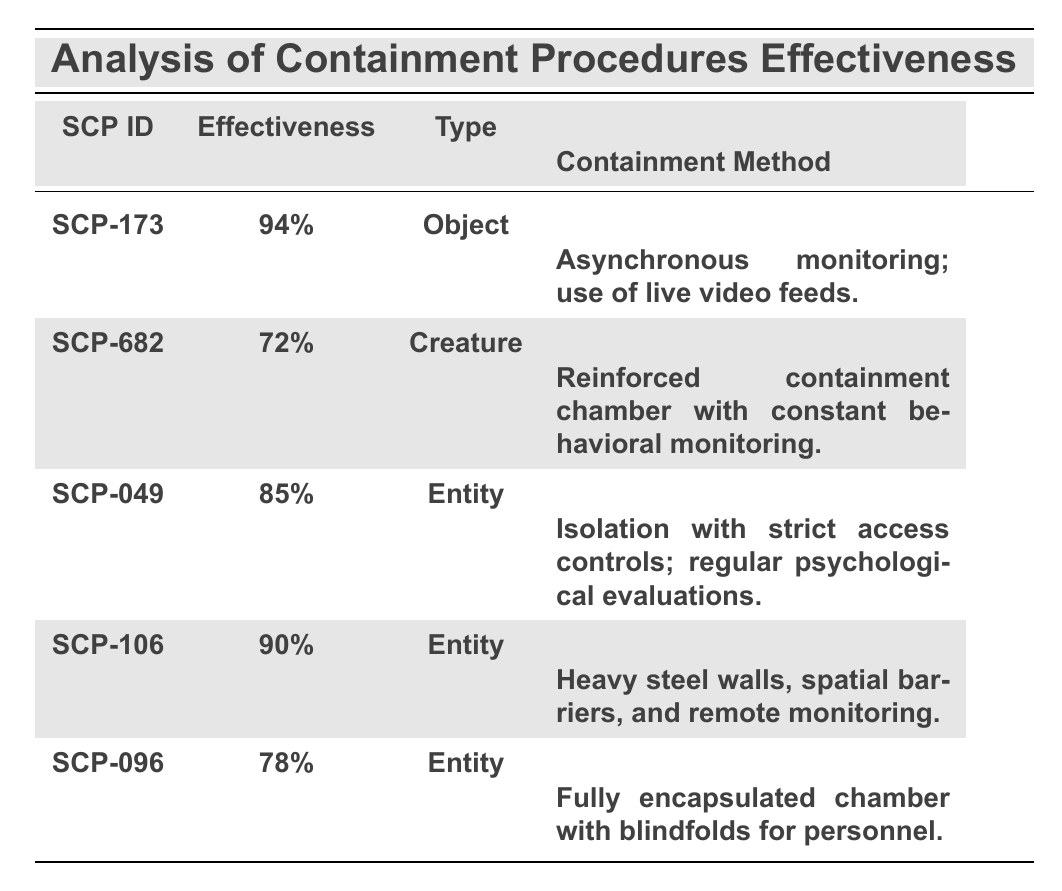What is the containment procedure effectiveness percentage for SCP-682? SCP-682's effectiveness percentage is provided directly in the table under the "Effectiveness" column. It shows "72%".
Answer: 72% Which SCP has the highest effectiveness in containment procedures? By comparing the effectiveness percentages listed in the table, SCP-173 has the highest at "94%".
Answer: SCP-173 How many SCPs listed have an effectiveness below 80%? The effectiveness percentages for SCP-682 (72%) and SCP-096 (78%) are both below 80%. Therefore, there are 2 SCPs.
Answer: 2 What containment method is used for SCP-106? The table directly indicates that SCP-106's containment method is "Heavy steel walls, spatial barriers, and remote monitoring."
Answer: Heavy steel walls, spatial barriers, and remote monitoring Is the effectiveness of SCP-049 greater than that of SCP-096? SCP-049's effectiveness is 85%, while SCP-096's effectiveness is 78%. Since 85% is greater than 78%, the statement is true.
Answer: Yes What is the average containment procedure effectiveness of all SCPs listed? First, sum the effectiveness percentages: 94 + 72 + 85 + 90 + 78 = 419. There are 5 SCPs, so to find the average, divide the sum by the number of SCPs: 419 / 5 = 83.8.
Answer: 83.8 Did SCP-049 have any incident reports related to unauthorized access? Looking at the incident reports for SCP-049 in the table shows one incident on "2022-08-13" where unauthorized access occurred. Therefore, the statement is true.
Answer: Yes Which SCP type has the lowest containment procedure effectiveness? Referring to the table, SCP-682 is a "Creature" type and has an effectiveness of 72%, which is the lowest compared to other types.
Answer: Creature (SCP-682) What incident led to a breach in SCP-173's containment? SCP-173's incident report dated "2022-03-15" states that it escaped due to a power outage affecting the surveillance system.
Answer: Power outage on 2022-03-15 Which SCPs are classified as "Entity" types? The table lists SCP-049, SCP-106, and SCP-096 as "Entity" types.
Answer: SCP-049, SCP-106, SCP-096 